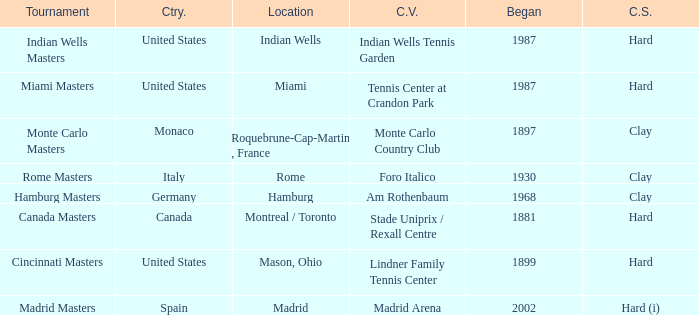Could you parse the entire table as a dict? {'header': ['Tournament', 'Ctry.', 'Location', 'C.V.', 'Began', 'C.S.'], 'rows': [['Indian Wells Masters', 'United States', 'Indian Wells', 'Indian Wells Tennis Garden', '1987', 'Hard'], ['Miami Masters', 'United States', 'Miami', 'Tennis Center at Crandon Park', '1987', 'Hard'], ['Monte Carlo Masters', 'Monaco', 'Roquebrune-Cap-Martin , France', 'Monte Carlo Country Club', '1897', 'Clay'], ['Rome Masters', 'Italy', 'Rome', 'Foro Italico', '1930', 'Clay'], ['Hamburg Masters', 'Germany', 'Hamburg', 'Am Rothenbaum', '1968', 'Clay'], ['Canada Masters', 'Canada', 'Montreal / Toronto', 'Stade Uniprix / Rexall Centre', '1881', 'Hard'], ['Cincinnati Masters', 'United States', 'Mason, Ohio', 'Lindner Family Tennis Center', '1899', 'Hard'], ['Madrid Masters', 'Spain', 'Madrid', 'Madrid Arena', '2002', 'Hard (i)']]} Which current venues location is Mason, Ohio? Lindner Family Tennis Center. 